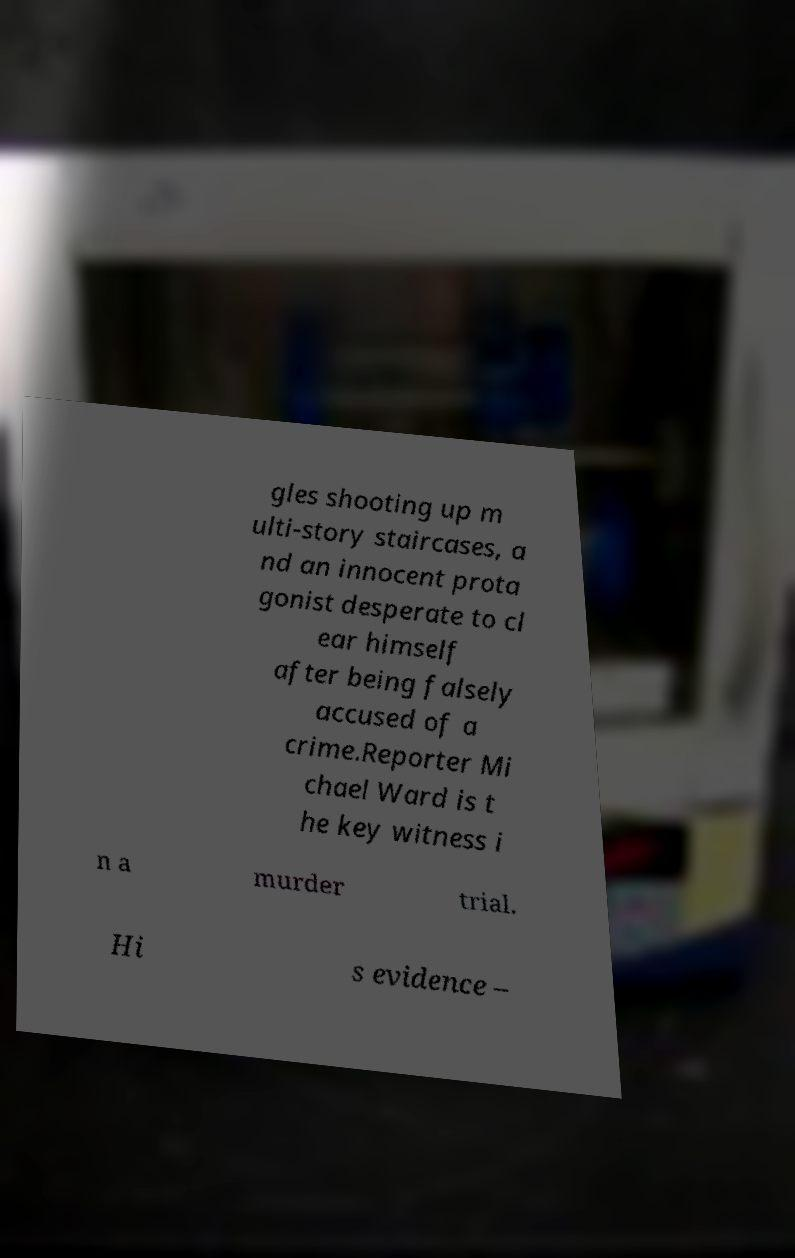Can you accurately transcribe the text from the provided image for me? gles shooting up m ulti-story staircases, a nd an innocent prota gonist desperate to cl ear himself after being falsely accused of a crime.Reporter Mi chael Ward is t he key witness i n a murder trial. Hi s evidence – 